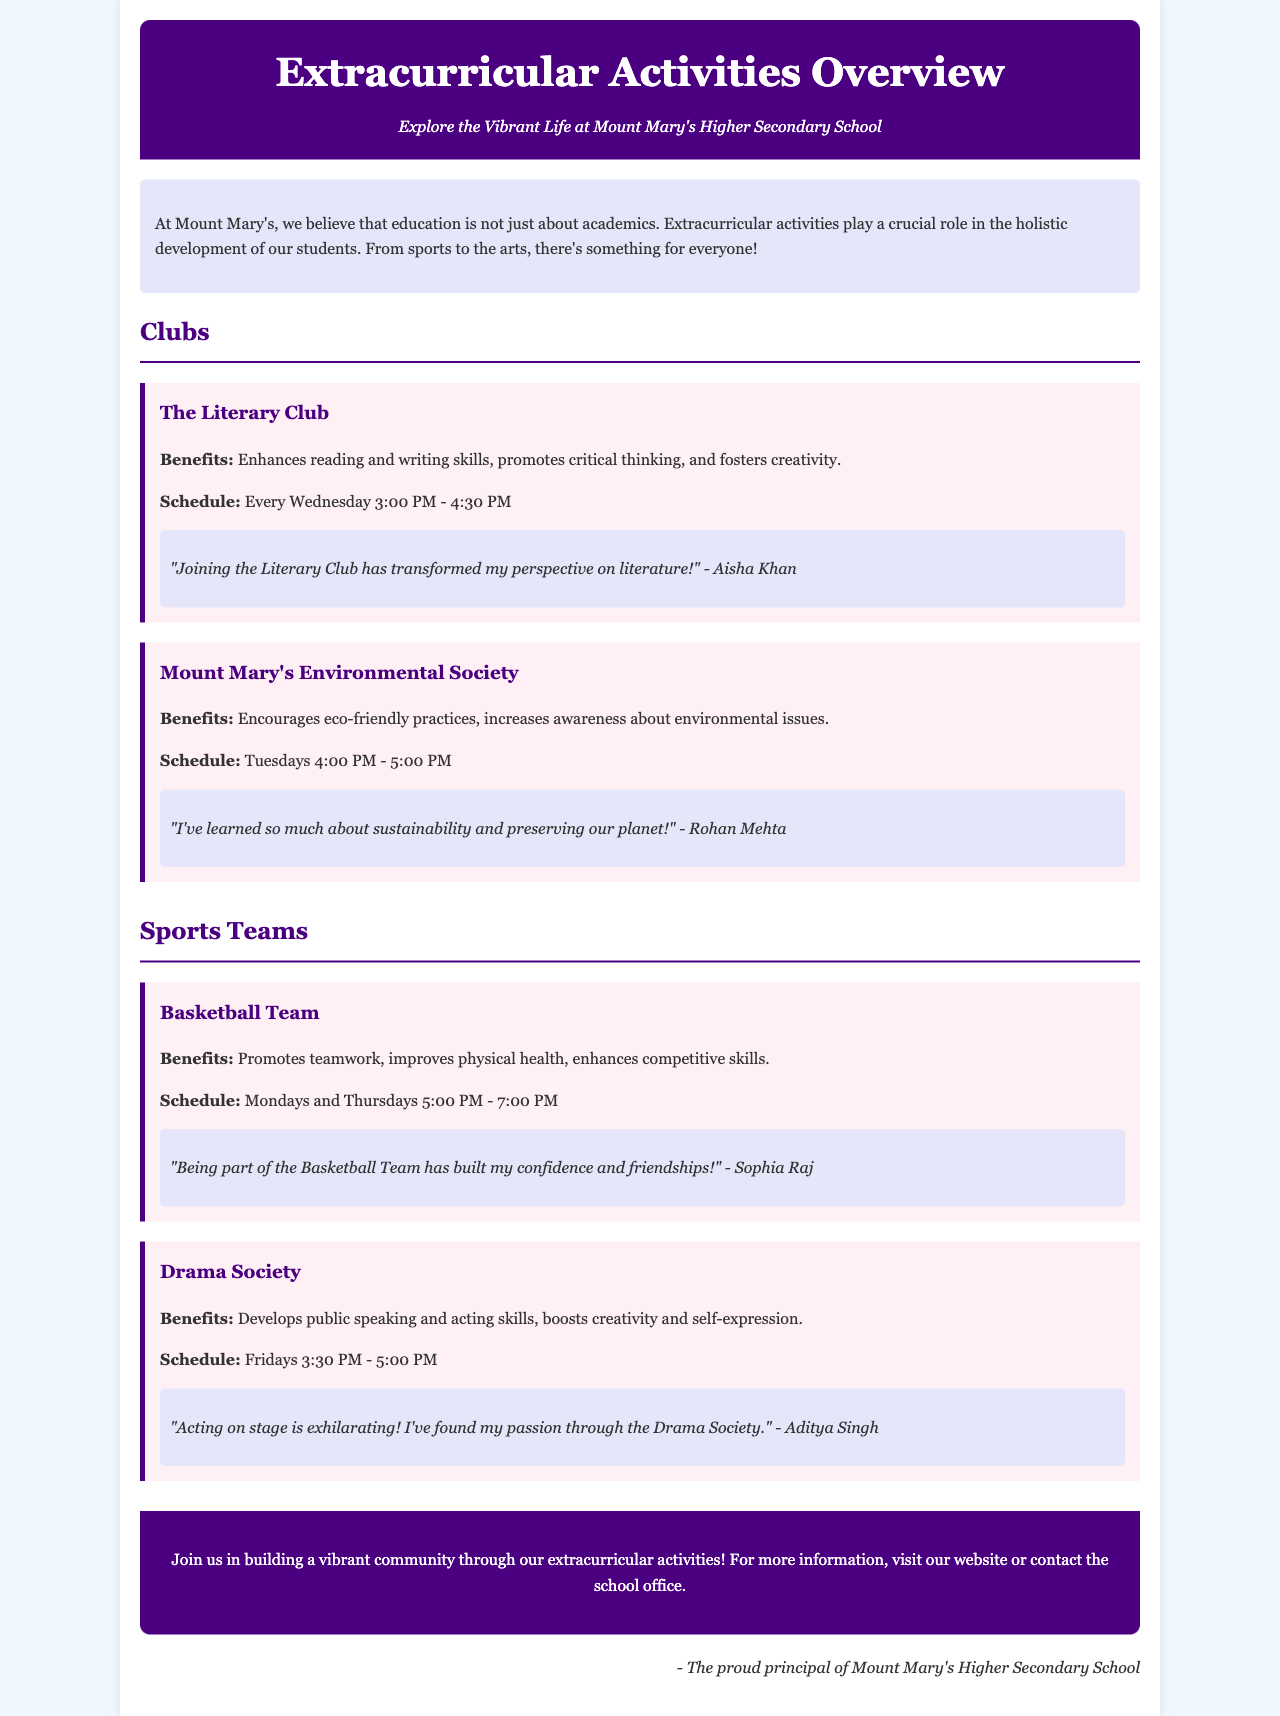What is the main focus of Mount Mary's extracurricular activities? The introduction highlights that education is not just about academics and that extracurricular activities play a crucial role in holistic development.
Answer: Holistic development When does the Literary Club meet? The schedule states that the Literary Club meets every Wednesday from 3:00 PM to 4:30 PM.
Answer: Every Wednesday 3:00 PM - 4:30 PM What benefit does the Basketball Team promote? The benefits listed for the Basketball Team include promoting teamwork among its members.
Answer: Teamwork Who is the testimonial from for the Environmental Society? The testimonial is credited to Rohan Mehta, who shares about learning sustainability.
Answer: Rohan Mehta How often does the Drama Society hold meetings? The schedule indicates that the Drama Society meets every Friday.
Answer: Every Friday What is the color scheme for the header of the brochure? The header background color is specified as #4b0082, which is a shade of purple.
Answer: #4b0082 What type of activities does Mount Mary's offer according to the brochure? The brochure highlights both clubs and sports teams as the main types of activities available.
Answer: Clubs and sports teams What does the brochure encourage readers to do? The call to action encourages readers to join and build a vibrant community through extracurricular activities.
Answer: Join us in building a vibrant community What is the signature noted at the end of the document? The signature shows that the information comes from the principal of Mount Mary's Higher Secondary School.
Answer: The proud principal of Mount Mary's Higher Secondary School 